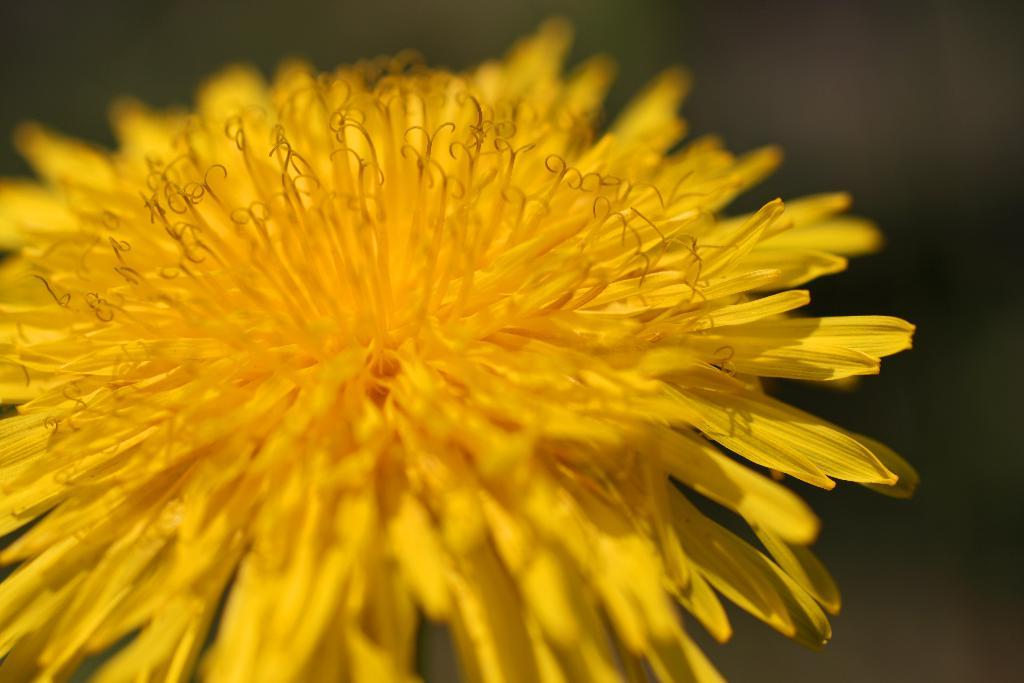What type of flower is present in the image? There is a yellow flower in the image. Can you describe the lighting or color in a specific area of the image? There is darkness on the top right of the image. What type of vest can be seen hanging on the yellow flower in the image? There is no vest present in the image, and the yellow flower is not a location where a vest could be hung. 